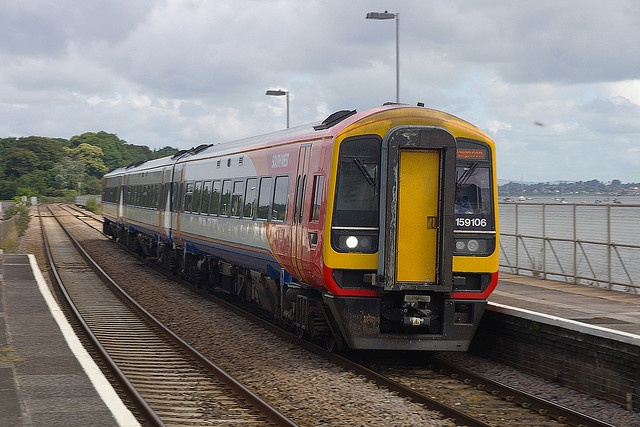Describe the objects in this image and their specific colors. I can see a train in lightgray, black, gray, darkgray, and olive tones in this image. 